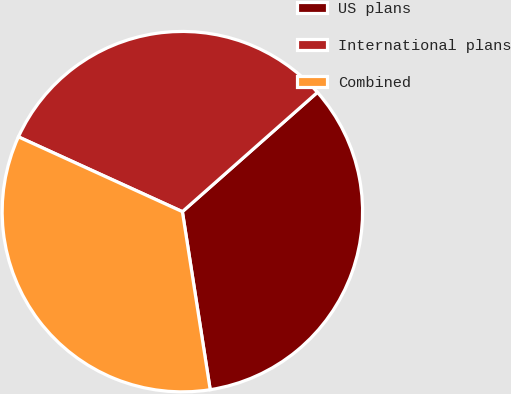Convert chart. <chart><loc_0><loc_0><loc_500><loc_500><pie_chart><fcel>US plans<fcel>International plans<fcel>Combined<nl><fcel>34.05%<fcel>31.67%<fcel>34.28%<nl></chart> 